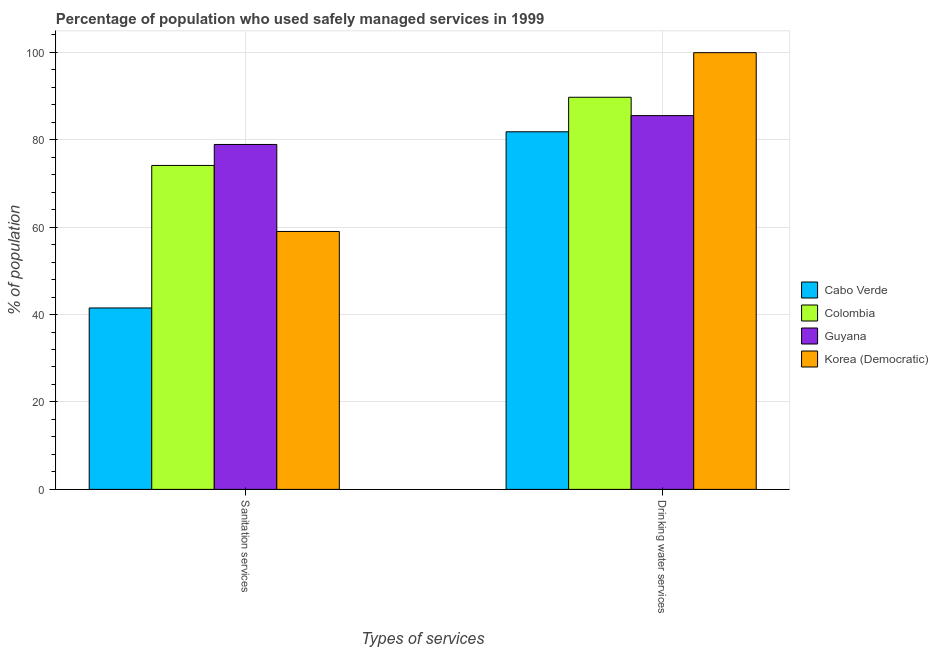How many groups of bars are there?
Give a very brief answer. 2. Are the number of bars on each tick of the X-axis equal?
Provide a short and direct response. Yes. How many bars are there on the 1st tick from the left?
Your response must be concise. 4. What is the label of the 2nd group of bars from the left?
Your response must be concise. Drinking water services. What is the percentage of population who used drinking water services in Korea (Democratic)?
Your response must be concise. 99.9. Across all countries, what is the maximum percentage of population who used drinking water services?
Provide a succinct answer. 99.9. Across all countries, what is the minimum percentage of population who used drinking water services?
Make the answer very short. 81.8. In which country was the percentage of population who used drinking water services maximum?
Your answer should be compact. Korea (Democratic). In which country was the percentage of population who used sanitation services minimum?
Provide a succinct answer. Cabo Verde. What is the total percentage of population who used sanitation services in the graph?
Your response must be concise. 253.5. What is the difference between the percentage of population who used sanitation services in Cabo Verde and that in Korea (Democratic)?
Offer a very short reply. -17.5. What is the difference between the percentage of population who used sanitation services in Colombia and the percentage of population who used drinking water services in Guyana?
Provide a succinct answer. -11.4. What is the average percentage of population who used sanitation services per country?
Your response must be concise. 63.38. What is the difference between the percentage of population who used drinking water services and percentage of population who used sanitation services in Colombia?
Provide a succinct answer. 15.6. In how many countries, is the percentage of population who used drinking water services greater than 68 %?
Ensure brevity in your answer.  4. What is the ratio of the percentage of population who used drinking water services in Guyana to that in Korea (Democratic)?
Offer a very short reply. 0.86. Is the percentage of population who used drinking water services in Guyana less than that in Cabo Verde?
Provide a succinct answer. No. What does the 3rd bar from the left in Drinking water services represents?
Your response must be concise. Guyana. What does the 1st bar from the right in Drinking water services represents?
Ensure brevity in your answer.  Korea (Democratic). How many countries are there in the graph?
Your answer should be compact. 4. What is the title of the graph?
Offer a very short reply. Percentage of population who used safely managed services in 1999. Does "Kuwait" appear as one of the legend labels in the graph?
Offer a terse response. No. What is the label or title of the X-axis?
Offer a terse response. Types of services. What is the label or title of the Y-axis?
Keep it short and to the point. % of population. What is the % of population of Cabo Verde in Sanitation services?
Your answer should be very brief. 41.5. What is the % of population of Colombia in Sanitation services?
Offer a terse response. 74.1. What is the % of population in Guyana in Sanitation services?
Your answer should be compact. 78.9. What is the % of population in Korea (Democratic) in Sanitation services?
Ensure brevity in your answer.  59. What is the % of population of Cabo Verde in Drinking water services?
Give a very brief answer. 81.8. What is the % of population of Colombia in Drinking water services?
Offer a very short reply. 89.7. What is the % of population of Guyana in Drinking water services?
Your response must be concise. 85.5. What is the % of population of Korea (Democratic) in Drinking water services?
Give a very brief answer. 99.9. Across all Types of services, what is the maximum % of population of Cabo Verde?
Give a very brief answer. 81.8. Across all Types of services, what is the maximum % of population in Colombia?
Ensure brevity in your answer.  89.7. Across all Types of services, what is the maximum % of population of Guyana?
Provide a short and direct response. 85.5. Across all Types of services, what is the maximum % of population in Korea (Democratic)?
Make the answer very short. 99.9. Across all Types of services, what is the minimum % of population in Cabo Verde?
Make the answer very short. 41.5. Across all Types of services, what is the minimum % of population in Colombia?
Give a very brief answer. 74.1. Across all Types of services, what is the minimum % of population in Guyana?
Provide a succinct answer. 78.9. What is the total % of population in Cabo Verde in the graph?
Provide a short and direct response. 123.3. What is the total % of population in Colombia in the graph?
Provide a succinct answer. 163.8. What is the total % of population in Guyana in the graph?
Provide a succinct answer. 164.4. What is the total % of population in Korea (Democratic) in the graph?
Make the answer very short. 158.9. What is the difference between the % of population of Cabo Verde in Sanitation services and that in Drinking water services?
Offer a very short reply. -40.3. What is the difference between the % of population of Colombia in Sanitation services and that in Drinking water services?
Ensure brevity in your answer.  -15.6. What is the difference between the % of population of Korea (Democratic) in Sanitation services and that in Drinking water services?
Offer a very short reply. -40.9. What is the difference between the % of population of Cabo Verde in Sanitation services and the % of population of Colombia in Drinking water services?
Ensure brevity in your answer.  -48.2. What is the difference between the % of population of Cabo Verde in Sanitation services and the % of population of Guyana in Drinking water services?
Provide a succinct answer. -44. What is the difference between the % of population of Cabo Verde in Sanitation services and the % of population of Korea (Democratic) in Drinking water services?
Provide a succinct answer. -58.4. What is the difference between the % of population in Colombia in Sanitation services and the % of population in Guyana in Drinking water services?
Give a very brief answer. -11.4. What is the difference between the % of population in Colombia in Sanitation services and the % of population in Korea (Democratic) in Drinking water services?
Offer a terse response. -25.8. What is the average % of population of Cabo Verde per Types of services?
Offer a very short reply. 61.65. What is the average % of population in Colombia per Types of services?
Provide a succinct answer. 81.9. What is the average % of population in Guyana per Types of services?
Provide a short and direct response. 82.2. What is the average % of population of Korea (Democratic) per Types of services?
Provide a succinct answer. 79.45. What is the difference between the % of population of Cabo Verde and % of population of Colombia in Sanitation services?
Provide a succinct answer. -32.6. What is the difference between the % of population of Cabo Verde and % of population of Guyana in Sanitation services?
Offer a terse response. -37.4. What is the difference between the % of population in Cabo Verde and % of population in Korea (Democratic) in Sanitation services?
Your response must be concise. -17.5. What is the difference between the % of population of Colombia and % of population of Guyana in Sanitation services?
Keep it short and to the point. -4.8. What is the difference between the % of population in Guyana and % of population in Korea (Democratic) in Sanitation services?
Your response must be concise. 19.9. What is the difference between the % of population of Cabo Verde and % of population of Colombia in Drinking water services?
Your response must be concise. -7.9. What is the difference between the % of population of Cabo Verde and % of population of Guyana in Drinking water services?
Your response must be concise. -3.7. What is the difference between the % of population in Cabo Verde and % of population in Korea (Democratic) in Drinking water services?
Provide a short and direct response. -18.1. What is the difference between the % of population in Colombia and % of population in Guyana in Drinking water services?
Keep it short and to the point. 4.2. What is the difference between the % of population of Guyana and % of population of Korea (Democratic) in Drinking water services?
Offer a terse response. -14.4. What is the ratio of the % of population of Cabo Verde in Sanitation services to that in Drinking water services?
Offer a very short reply. 0.51. What is the ratio of the % of population in Colombia in Sanitation services to that in Drinking water services?
Offer a very short reply. 0.83. What is the ratio of the % of population of Guyana in Sanitation services to that in Drinking water services?
Offer a very short reply. 0.92. What is the ratio of the % of population of Korea (Democratic) in Sanitation services to that in Drinking water services?
Keep it short and to the point. 0.59. What is the difference between the highest and the second highest % of population in Cabo Verde?
Offer a very short reply. 40.3. What is the difference between the highest and the second highest % of population in Guyana?
Offer a terse response. 6.6. What is the difference between the highest and the second highest % of population in Korea (Democratic)?
Offer a very short reply. 40.9. What is the difference between the highest and the lowest % of population of Cabo Verde?
Give a very brief answer. 40.3. What is the difference between the highest and the lowest % of population of Guyana?
Make the answer very short. 6.6. What is the difference between the highest and the lowest % of population in Korea (Democratic)?
Your answer should be very brief. 40.9. 